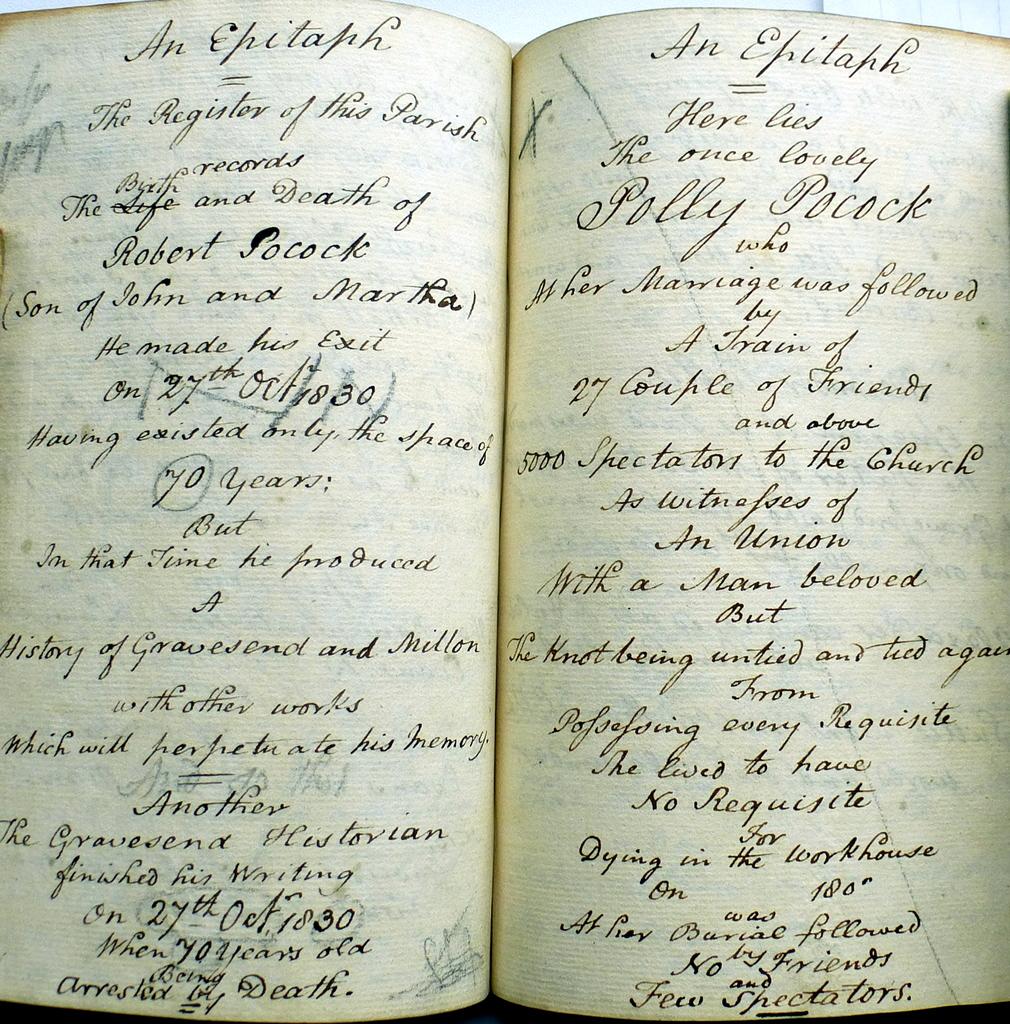Are the persons in the epitaphs related?
Your answer should be compact. Unanswerable. 